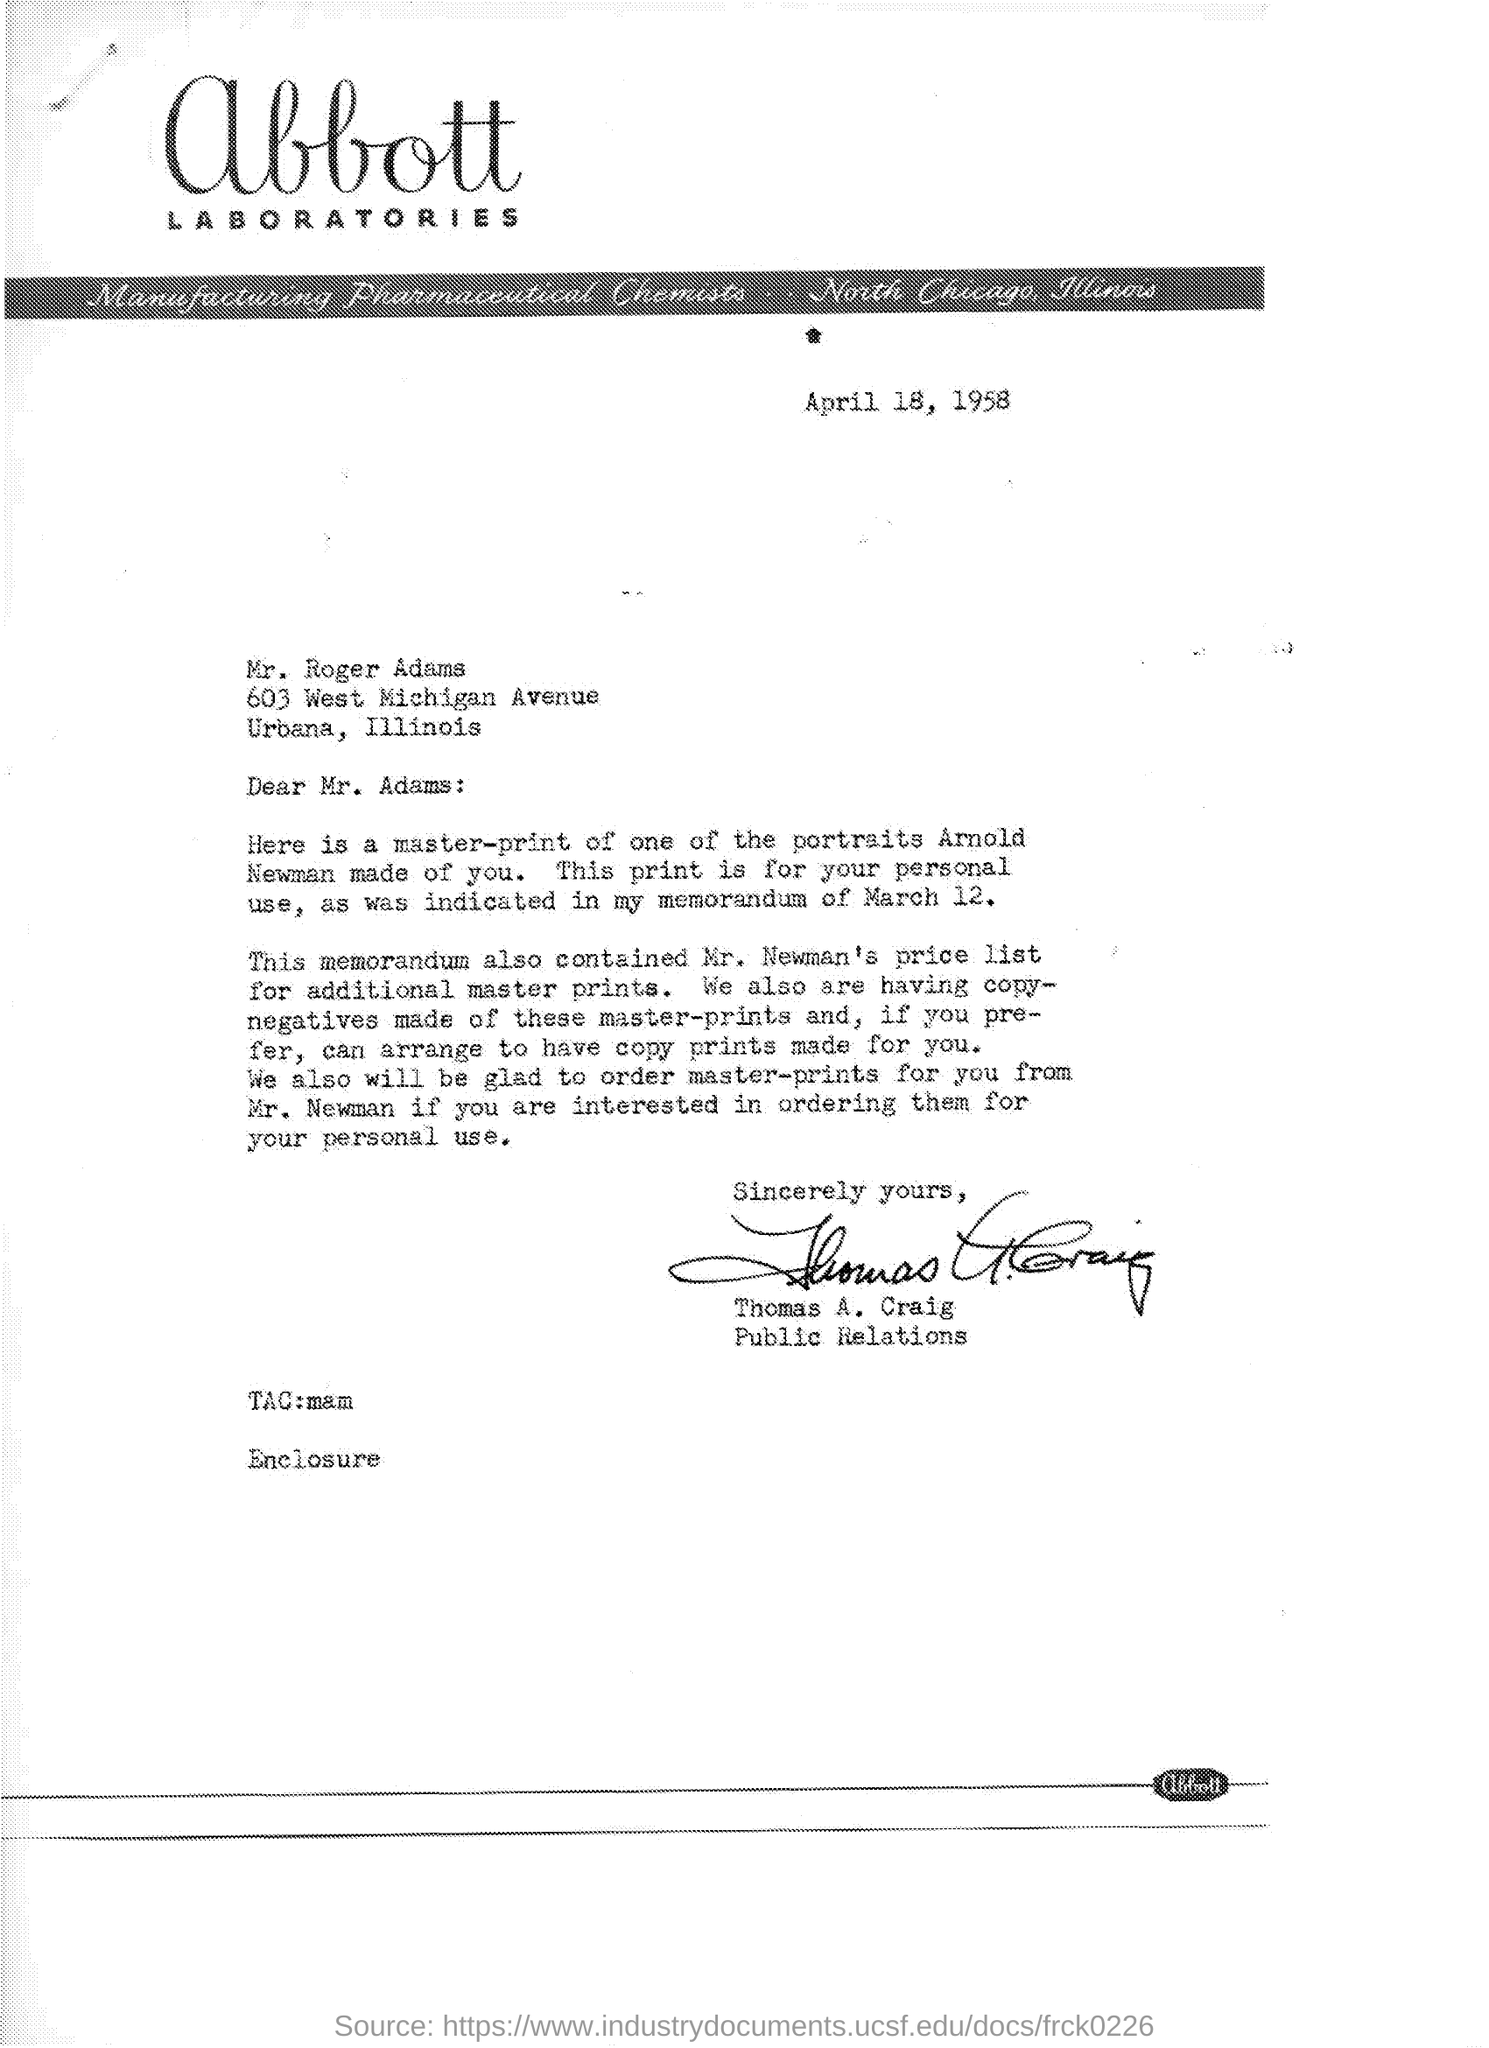Who is sender?
Your answer should be compact. Thomas A. Craig. Date of the memorandum?
Offer a terse response. March 12. Where is the place "Urbanas" ?
Your answer should be very brief. Illinois. 